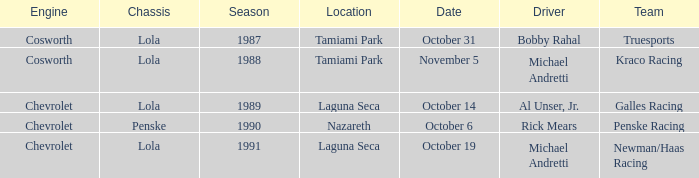Which team raced on October 19? Newman/Haas Racing. 